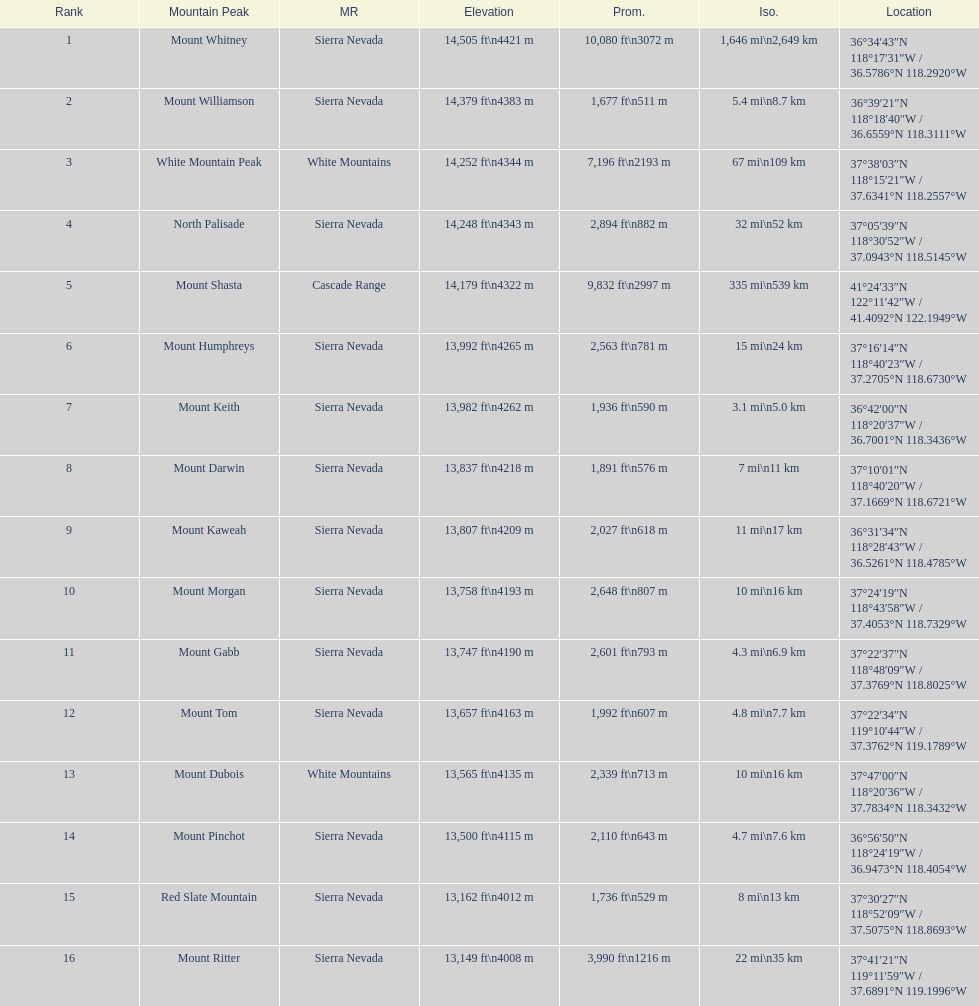Which is taller, mount humphreys or mount kaweah. Mount Humphreys. 